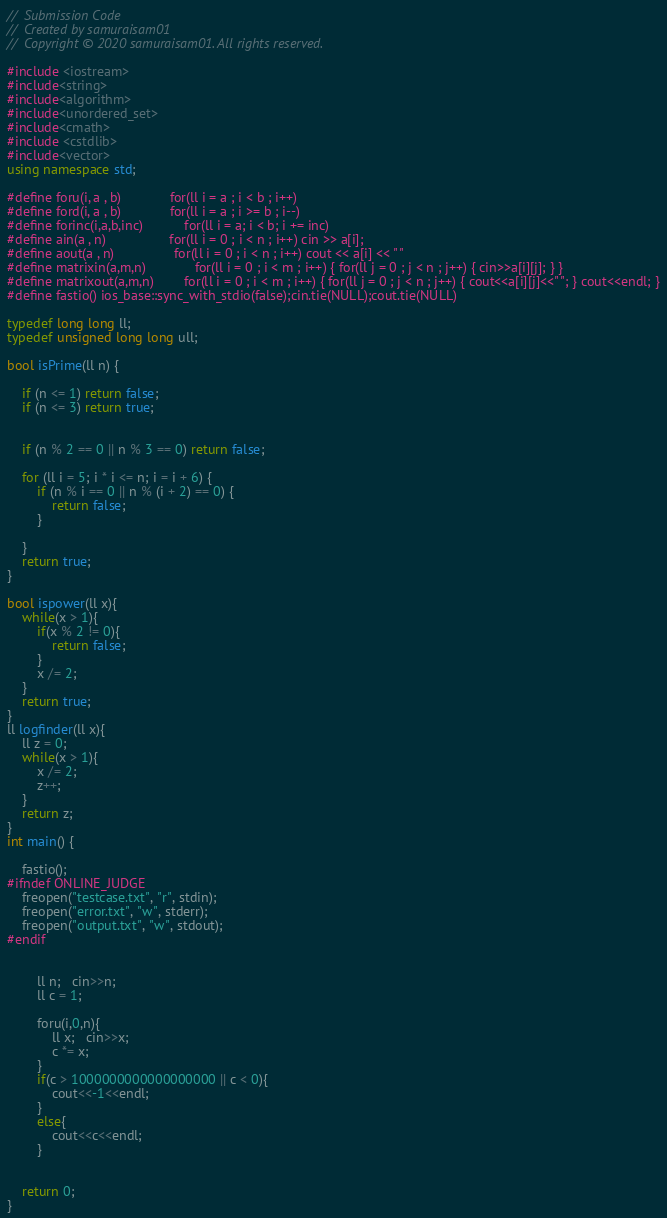Convert code to text. <code><loc_0><loc_0><loc_500><loc_500><_C++_>//  Submission Code
//  Created by samuraisam01
//  Copyright © 2020 samuraisam01. All rights reserved.

#include <iostream>
#include<string>
#include<algorithm>
#include<unordered_set>
#include<cmath>
#include <cstdlib>
#include<vector>
using namespace std;

#define foru(i, a , b)             for(ll i = a ; i < b ; i++)
#define ford(i, a , b)             for(ll i = a ; i >= b ; i--)
#define forinc(i,a,b,inc)           for(ll i = a; i < b; i += inc)
#define ain(a , n)                 for(ll i = 0 ; i < n ; i++) cin >> a[i];
#define aout(a , n)                for(ll i = 0 ; i < n ; i++) cout << a[i] << " "
#define matrixin(a,m,n)			   for(ll i = 0 ; i < m ; i++) { for(ll j = 0 ; j < n ; j++) { cin>>a[i][j]; } }
#define matrixout(a,m,n)		   for(ll i = 0 ; i < m ; i++) { for(ll j = 0 ; j < n ; j++) { cout<<a[i][j]<<" "; } cout<<endl; }
#define fastio() ios_base::sync_with_stdio(false);cin.tie(NULL);cout.tie(NULL)

typedef long long ll;
typedef unsigned long long ull;

bool isPrime(ll n) {

    if (n <= 1) return false;
    if (n <= 3) return true;


    if (n % 2 == 0 || n % 3 == 0) return false;

    for (ll i = 5; i * i <= n; i = i + 6) {
        if (n % i == 0 || n % (i + 2) == 0) {
            return false;
        }

    }
    return true;
}

bool ispower(ll x){
    while(x > 1){
        if(x % 2 != 0){
            return false;
        }
        x /= 2;
    }
    return true;
}
ll logfinder(ll x){
    ll z = 0;
    while(x > 1){
        x /= 2;
        z++;
    }
    return z;
}
int main() {

    fastio();
#ifndef ONLINE_JUDGE
    freopen("testcase.txt", "r", stdin);
    freopen("error.txt", "w", stderr);
    freopen("output.txt", "w", stdout);
#endif


        ll n;   cin>>n;
        ll c = 1;

        foru(i,0,n){
            ll x;   cin>>x;
            c *= x;
        }
        if(c > 1000000000000000000 || c < 0){
            cout<<-1<<endl;
        }
        else{
            cout<<c<<endl;
        }


    return 0;
}</code> 